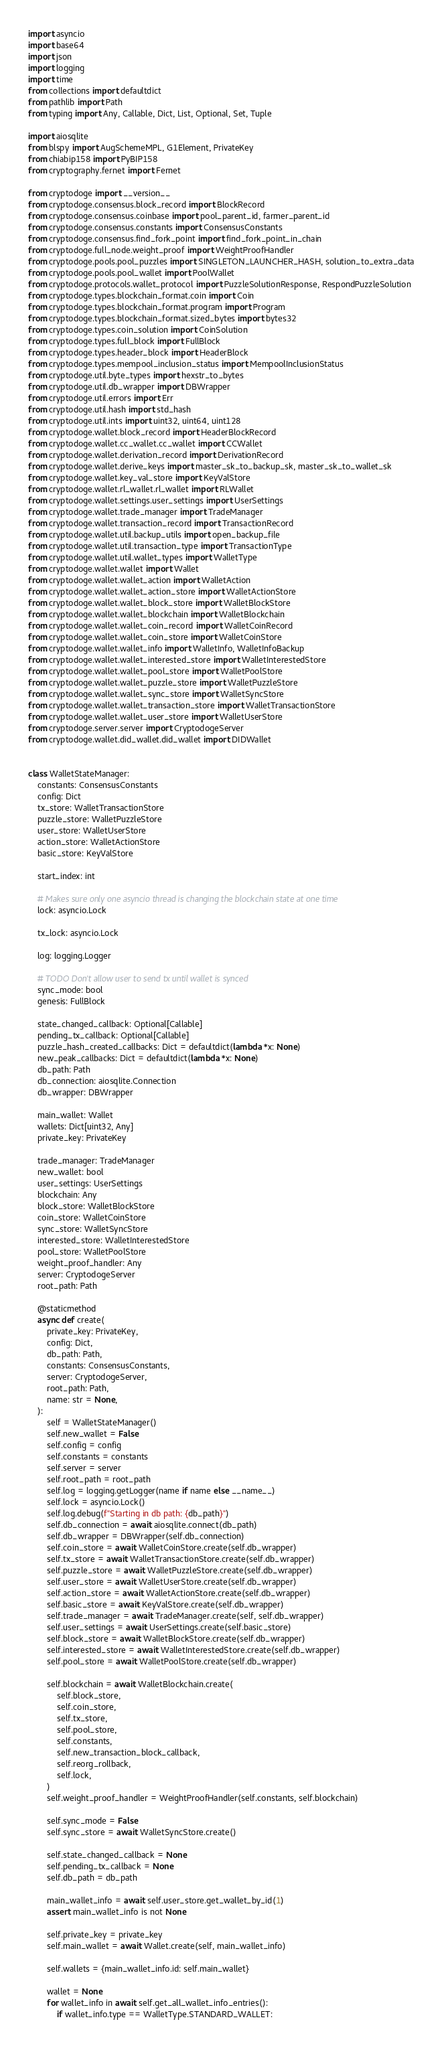<code> <loc_0><loc_0><loc_500><loc_500><_Python_>import asyncio
import base64
import json
import logging
import time
from collections import defaultdict
from pathlib import Path
from typing import Any, Callable, Dict, List, Optional, Set, Tuple

import aiosqlite
from blspy import AugSchemeMPL, G1Element, PrivateKey
from chiabip158 import PyBIP158
from cryptography.fernet import Fernet

from cryptodoge import __version__
from cryptodoge.consensus.block_record import BlockRecord
from cryptodoge.consensus.coinbase import pool_parent_id, farmer_parent_id
from cryptodoge.consensus.constants import ConsensusConstants
from cryptodoge.consensus.find_fork_point import find_fork_point_in_chain
from cryptodoge.full_node.weight_proof import WeightProofHandler
from cryptodoge.pools.pool_puzzles import SINGLETON_LAUNCHER_HASH, solution_to_extra_data
from cryptodoge.pools.pool_wallet import PoolWallet
from cryptodoge.protocols.wallet_protocol import PuzzleSolutionResponse, RespondPuzzleSolution
from cryptodoge.types.blockchain_format.coin import Coin
from cryptodoge.types.blockchain_format.program import Program
from cryptodoge.types.blockchain_format.sized_bytes import bytes32
from cryptodoge.types.coin_solution import CoinSolution
from cryptodoge.types.full_block import FullBlock
from cryptodoge.types.header_block import HeaderBlock
from cryptodoge.types.mempool_inclusion_status import MempoolInclusionStatus
from cryptodoge.util.byte_types import hexstr_to_bytes
from cryptodoge.util.db_wrapper import DBWrapper
from cryptodoge.util.errors import Err
from cryptodoge.util.hash import std_hash
from cryptodoge.util.ints import uint32, uint64, uint128
from cryptodoge.wallet.block_record import HeaderBlockRecord
from cryptodoge.wallet.cc_wallet.cc_wallet import CCWallet
from cryptodoge.wallet.derivation_record import DerivationRecord
from cryptodoge.wallet.derive_keys import master_sk_to_backup_sk, master_sk_to_wallet_sk
from cryptodoge.wallet.key_val_store import KeyValStore
from cryptodoge.wallet.rl_wallet.rl_wallet import RLWallet
from cryptodoge.wallet.settings.user_settings import UserSettings
from cryptodoge.wallet.trade_manager import TradeManager
from cryptodoge.wallet.transaction_record import TransactionRecord
from cryptodoge.wallet.util.backup_utils import open_backup_file
from cryptodoge.wallet.util.transaction_type import TransactionType
from cryptodoge.wallet.util.wallet_types import WalletType
from cryptodoge.wallet.wallet import Wallet
from cryptodoge.wallet.wallet_action import WalletAction
from cryptodoge.wallet.wallet_action_store import WalletActionStore
from cryptodoge.wallet.wallet_block_store import WalletBlockStore
from cryptodoge.wallet.wallet_blockchain import WalletBlockchain
from cryptodoge.wallet.wallet_coin_record import WalletCoinRecord
from cryptodoge.wallet.wallet_coin_store import WalletCoinStore
from cryptodoge.wallet.wallet_info import WalletInfo, WalletInfoBackup
from cryptodoge.wallet.wallet_interested_store import WalletInterestedStore
from cryptodoge.wallet.wallet_pool_store import WalletPoolStore
from cryptodoge.wallet.wallet_puzzle_store import WalletPuzzleStore
from cryptodoge.wallet.wallet_sync_store import WalletSyncStore
from cryptodoge.wallet.wallet_transaction_store import WalletTransactionStore
from cryptodoge.wallet.wallet_user_store import WalletUserStore
from cryptodoge.server.server import CryptodogeServer
from cryptodoge.wallet.did_wallet.did_wallet import DIDWallet


class WalletStateManager:
    constants: ConsensusConstants
    config: Dict
    tx_store: WalletTransactionStore
    puzzle_store: WalletPuzzleStore
    user_store: WalletUserStore
    action_store: WalletActionStore
    basic_store: KeyValStore

    start_index: int

    # Makes sure only one asyncio thread is changing the blockchain state at one time
    lock: asyncio.Lock

    tx_lock: asyncio.Lock

    log: logging.Logger

    # TODO Don't allow user to send tx until wallet is synced
    sync_mode: bool
    genesis: FullBlock

    state_changed_callback: Optional[Callable]
    pending_tx_callback: Optional[Callable]
    puzzle_hash_created_callbacks: Dict = defaultdict(lambda *x: None)
    new_peak_callbacks: Dict = defaultdict(lambda *x: None)
    db_path: Path
    db_connection: aiosqlite.Connection
    db_wrapper: DBWrapper

    main_wallet: Wallet
    wallets: Dict[uint32, Any]
    private_key: PrivateKey

    trade_manager: TradeManager
    new_wallet: bool
    user_settings: UserSettings
    blockchain: Any
    block_store: WalletBlockStore
    coin_store: WalletCoinStore
    sync_store: WalletSyncStore
    interested_store: WalletInterestedStore
    pool_store: WalletPoolStore
    weight_proof_handler: Any
    server: CryptodogeServer
    root_path: Path

    @staticmethod
    async def create(
        private_key: PrivateKey,
        config: Dict,
        db_path: Path,
        constants: ConsensusConstants,
        server: CryptodogeServer,
        root_path: Path,
        name: str = None,
    ):
        self = WalletStateManager()
        self.new_wallet = False
        self.config = config
        self.constants = constants
        self.server = server
        self.root_path = root_path
        self.log = logging.getLogger(name if name else __name__)
        self.lock = asyncio.Lock()
        self.log.debug(f"Starting in db path: {db_path}")
        self.db_connection = await aiosqlite.connect(db_path)
        self.db_wrapper = DBWrapper(self.db_connection)
        self.coin_store = await WalletCoinStore.create(self.db_wrapper)
        self.tx_store = await WalletTransactionStore.create(self.db_wrapper)
        self.puzzle_store = await WalletPuzzleStore.create(self.db_wrapper)
        self.user_store = await WalletUserStore.create(self.db_wrapper)
        self.action_store = await WalletActionStore.create(self.db_wrapper)
        self.basic_store = await KeyValStore.create(self.db_wrapper)
        self.trade_manager = await TradeManager.create(self, self.db_wrapper)
        self.user_settings = await UserSettings.create(self.basic_store)
        self.block_store = await WalletBlockStore.create(self.db_wrapper)
        self.interested_store = await WalletInterestedStore.create(self.db_wrapper)
        self.pool_store = await WalletPoolStore.create(self.db_wrapper)

        self.blockchain = await WalletBlockchain.create(
            self.block_store,
            self.coin_store,
            self.tx_store,
            self.pool_store,
            self.constants,
            self.new_transaction_block_callback,
            self.reorg_rollback,
            self.lock,
        )
        self.weight_proof_handler = WeightProofHandler(self.constants, self.blockchain)

        self.sync_mode = False
        self.sync_store = await WalletSyncStore.create()

        self.state_changed_callback = None
        self.pending_tx_callback = None
        self.db_path = db_path

        main_wallet_info = await self.user_store.get_wallet_by_id(1)
        assert main_wallet_info is not None

        self.private_key = private_key
        self.main_wallet = await Wallet.create(self, main_wallet_info)

        self.wallets = {main_wallet_info.id: self.main_wallet}

        wallet = None
        for wallet_info in await self.get_all_wallet_info_entries():
            if wallet_info.type == WalletType.STANDARD_WALLET:</code> 